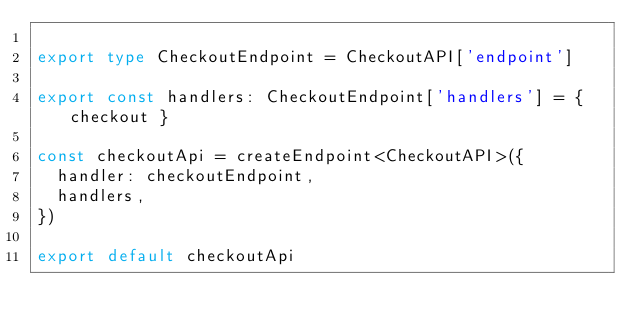<code> <loc_0><loc_0><loc_500><loc_500><_TypeScript_>
export type CheckoutEndpoint = CheckoutAPI['endpoint']

export const handlers: CheckoutEndpoint['handlers'] = { checkout }

const checkoutApi = createEndpoint<CheckoutAPI>({
  handler: checkoutEndpoint,
  handlers,
})

export default checkoutApi
</code> 